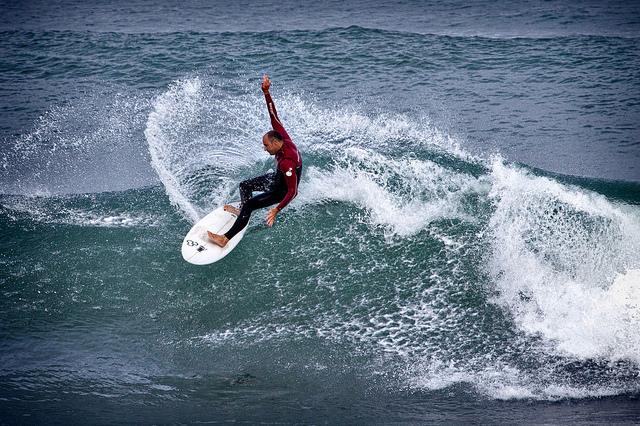Why might the man not want gloves on?
Answer briefly. Comfort. Is the surfer wearing a wetsuit?
Quick response, please. Yes. What color is the water?
Be succinct. Blue. Does the board have more than one color?
Quick response, please. Yes. Was the surfer in the process of changing direction when the photo was taken?
Be succinct. Yes. What color is the surfer's shorts?
Give a very brief answer. Black. 